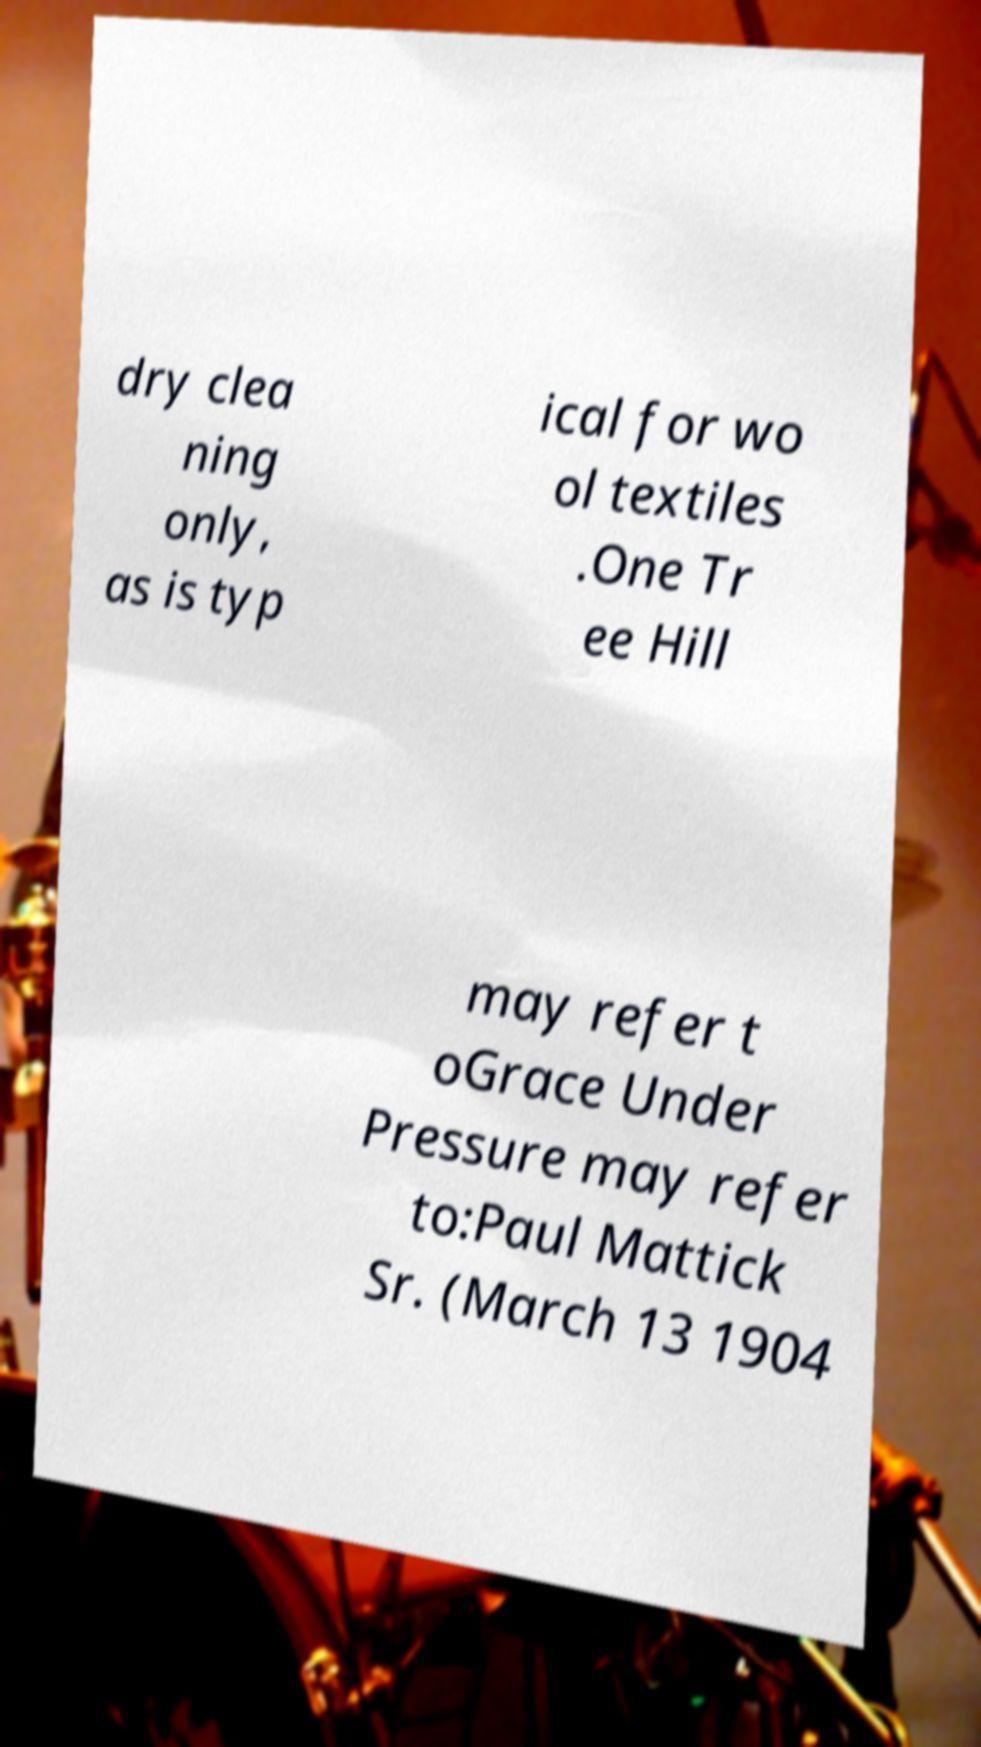Can you accurately transcribe the text from the provided image for me? dry clea ning only, as is typ ical for wo ol textiles .One Tr ee Hill may refer t oGrace Under Pressure may refer to:Paul Mattick Sr. (March 13 1904 